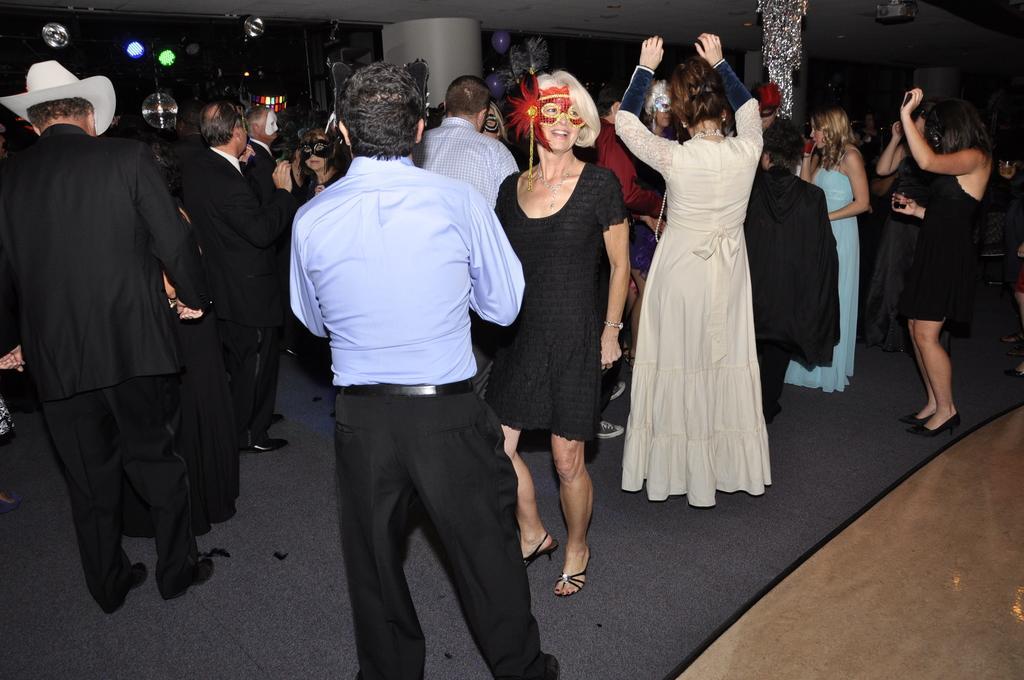Can you describe this image briefly? The picture is taken during a party. In the center of the picture there are many people dancing on your floor, many people are wearing masks. On the left there are lights. In the center of the background there are balloons. On the right it is floor. On the top right there is a projector. 